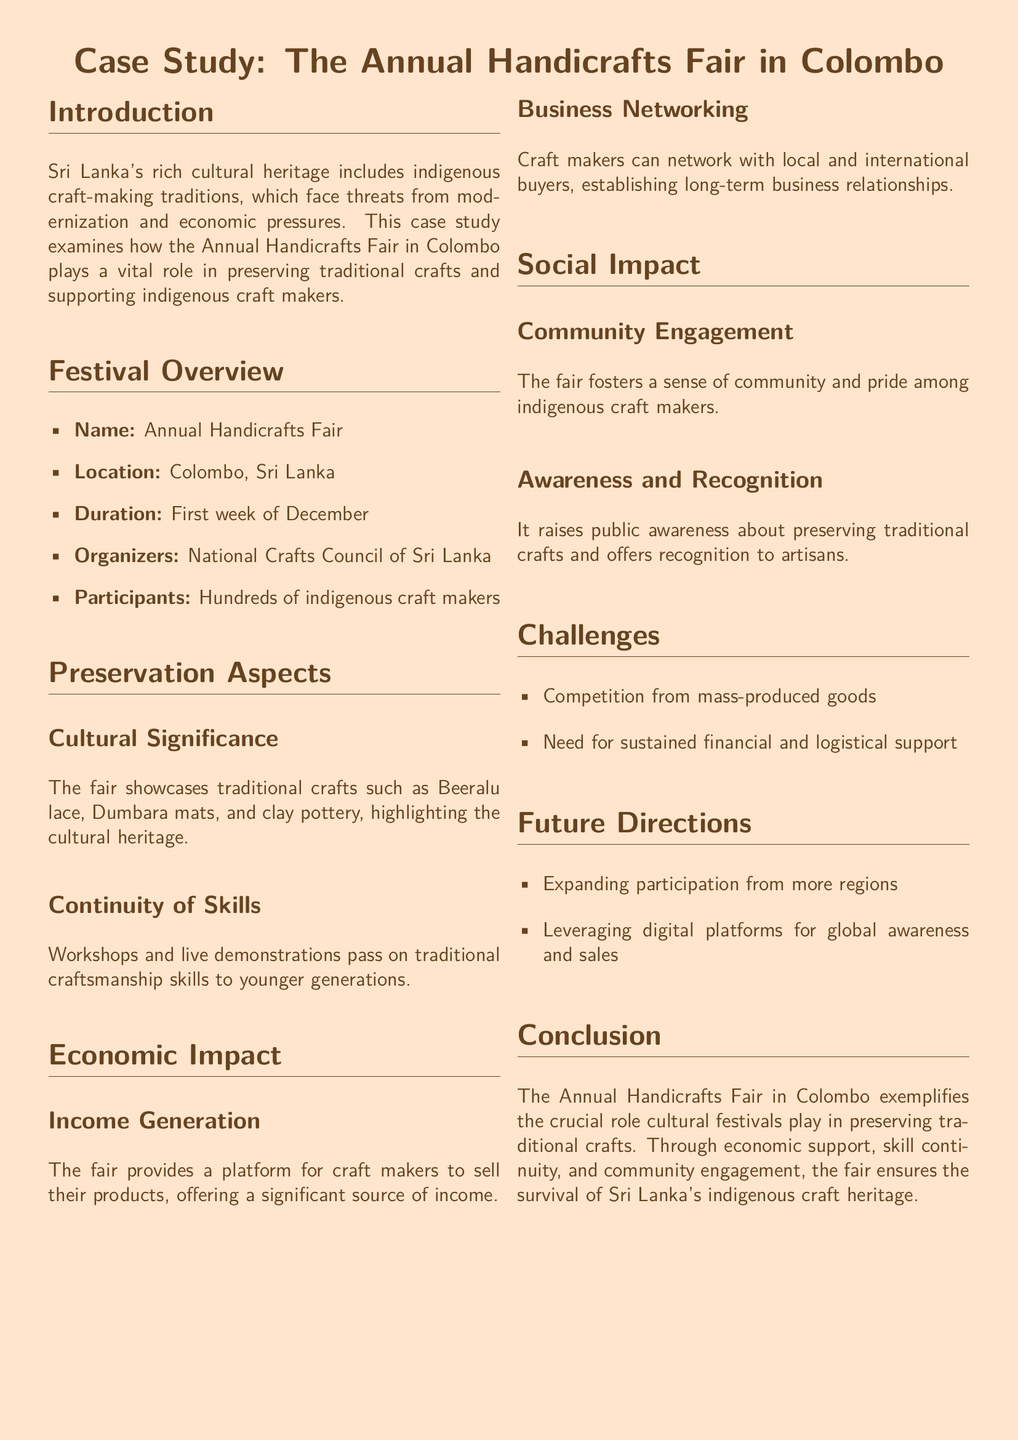What is the name of the festival? The name of the festival is stated in the document, specifically in the Festival Overview section.
Answer: Annual Handicrafts Fair Where is the festival held? The document mentions the location of the festival in the Festival Overview section.
Answer: Colombo, Sri Lanka How long does the festival last? The duration of the festival is provided in the Festival Overview section, giving a specific time frame.
Answer: First week of December Who organizes the festival? The organizer's name is included in the Festival Overview section of the document.
Answer: National Crafts Council of Sri Lanka What traditional craft is highlighted in the document? The document lists several traditional crafts in the Cultural Significance subsection.
Answer: Beeralu lace What is one challenge mentioned in the document? The challenges faced are identified in the Challenges section.
Answer: Competition from mass-produced goods What is the social impact of the festival? The social impact is described in the Social Impact section, specifically regarding community feelings.
Answer: Community engagement What is one future direction for the festival? Future directions are outlined in the Future Directions section of the document.
Answer: Expanding participation from more regions 